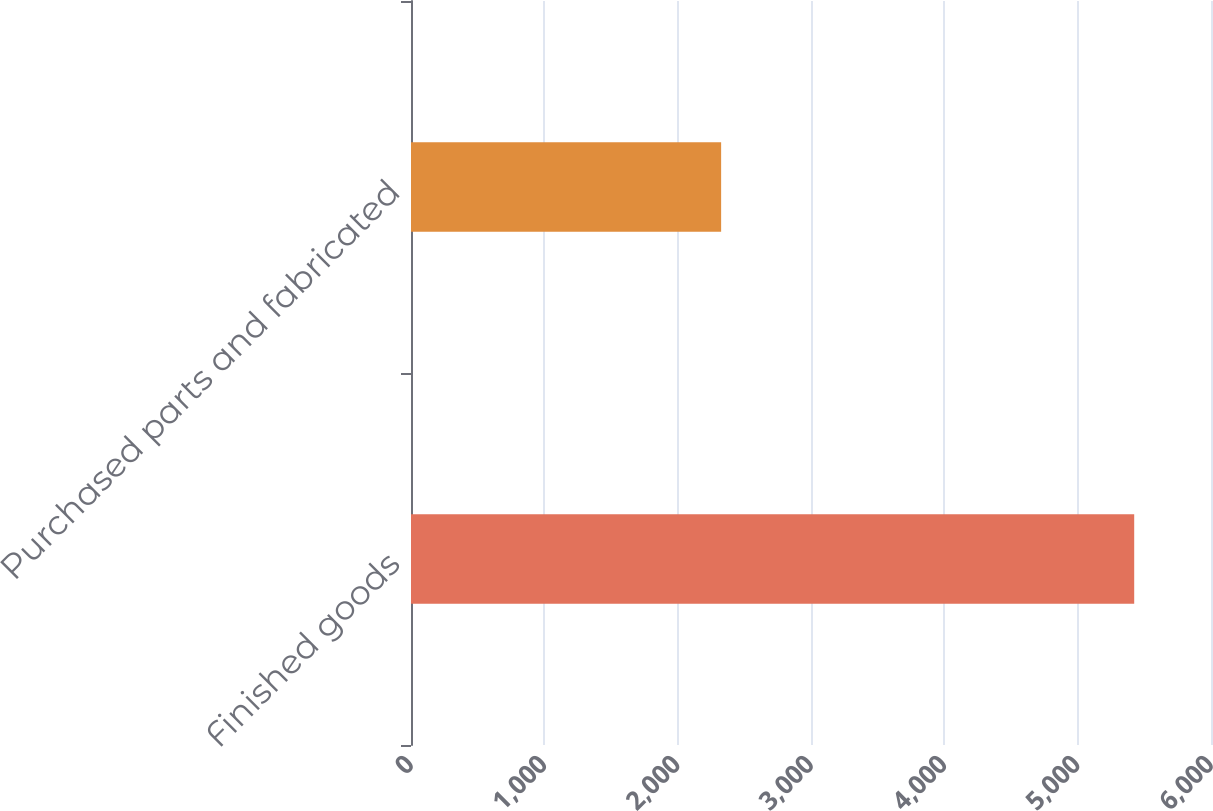Convert chart. <chart><loc_0><loc_0><loc_500><loc_500><bar_chart><fcel>Finished goods<fcel>Purchased parts and fabricated<nl><fcel>5424<fcel>2326<nl></chart> 